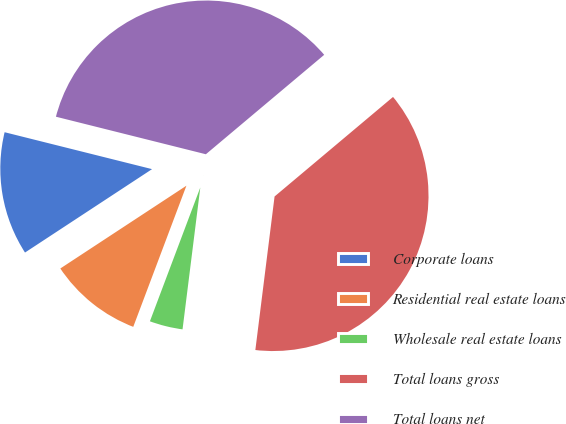<chart> <loc_0><loc_0><loc_500><loc_500><pie_chart><fcel>Corporate loans<fcel>Residential real estate loans<fcel>Wholesale real estate loans<fcel>Total loans gross<fcel>Total loans net<nl><fcel>13.15%<fcel>10.02%<fcel>3.75%<fcel>38.1%<fcel>34.97%<nl></chart> 